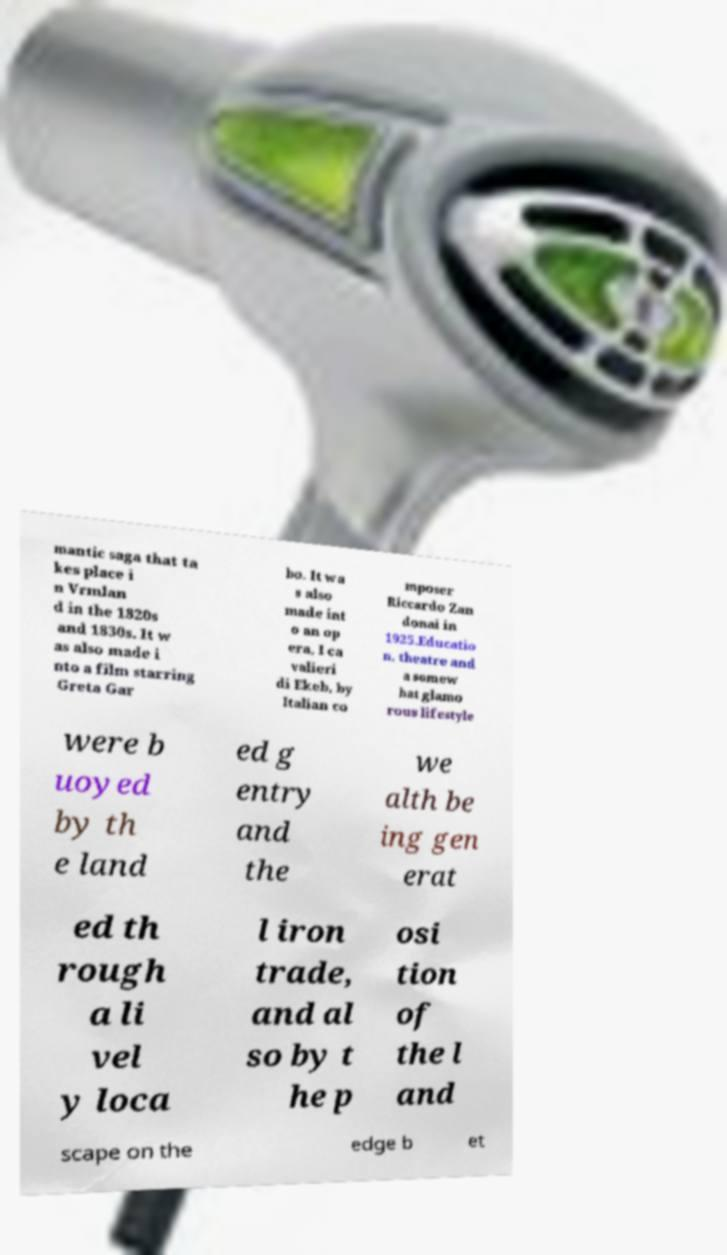What messages or text are displayed in this image? I need them in a readable, typed format. mantic saga that ta kes place i n Vrmlan d in the 1820s and 1830s. It w as also made i nto a film starring Greta Gar bo. It wa s also made int o an op era, I ca valieri di Ekeb, by Italian co mposer Riccardo Zan donai in 1925.Educatio n, theatre and a somew hat glamo rous lifestyle were b uoyed by th e land ed g entry and the we alth be ing gen erat ed th rough a li vel y loca l iron trade, and al so by t he p osi tion of the l and scape on the edge b et 